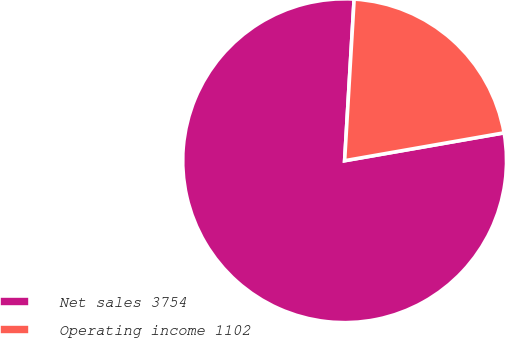Convert chart to OTSL. <chart><loc_0><loc_0><loc_500><loc_500><pie_chart><fcel>Net sales 3754<fcel>Operating income 1102<nl><fcel>78.69%<fcel>21.31%<nl></chart> 